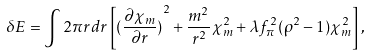Convert formula to latex. <formula><loc_0><loc_0><loc_500><loc_500>\delta E = \int 2 \pi r d r \left [ { ( \frac { \partial \chi _ { m } } { \partial r } ) } ^ { 2 } + \frac { m ^ { 2 } } { r ^ { 2 } } \chi _ { m } ^ { 2 } + \lambda f _ { \pi } ^ { 2 } ( \rho ^ { 2 } - 1 ) \chi _ { m } ^ { 2 } \right ] ,</formula> 